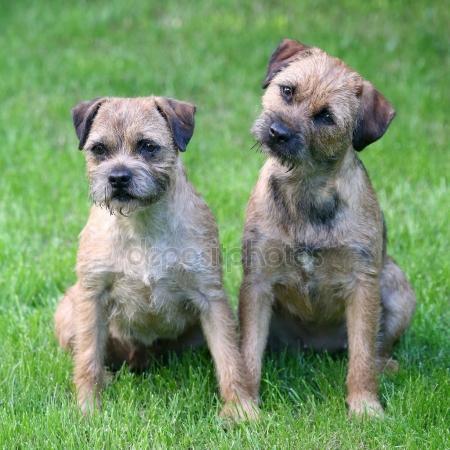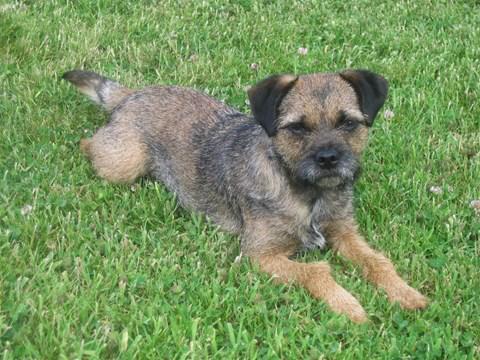The first image is the image on the left, the second image is the image on the right. Assess this claim about the two images: "Three dogs are relaxing outside in the grass.". Correct or not? Answer yes or no. Yes. The first image is the image on the left, the second image is the image on the right. Assess this claim about the two images: "There are three dogs exactly.". Correct or not? Answer yes or no. Yes. 